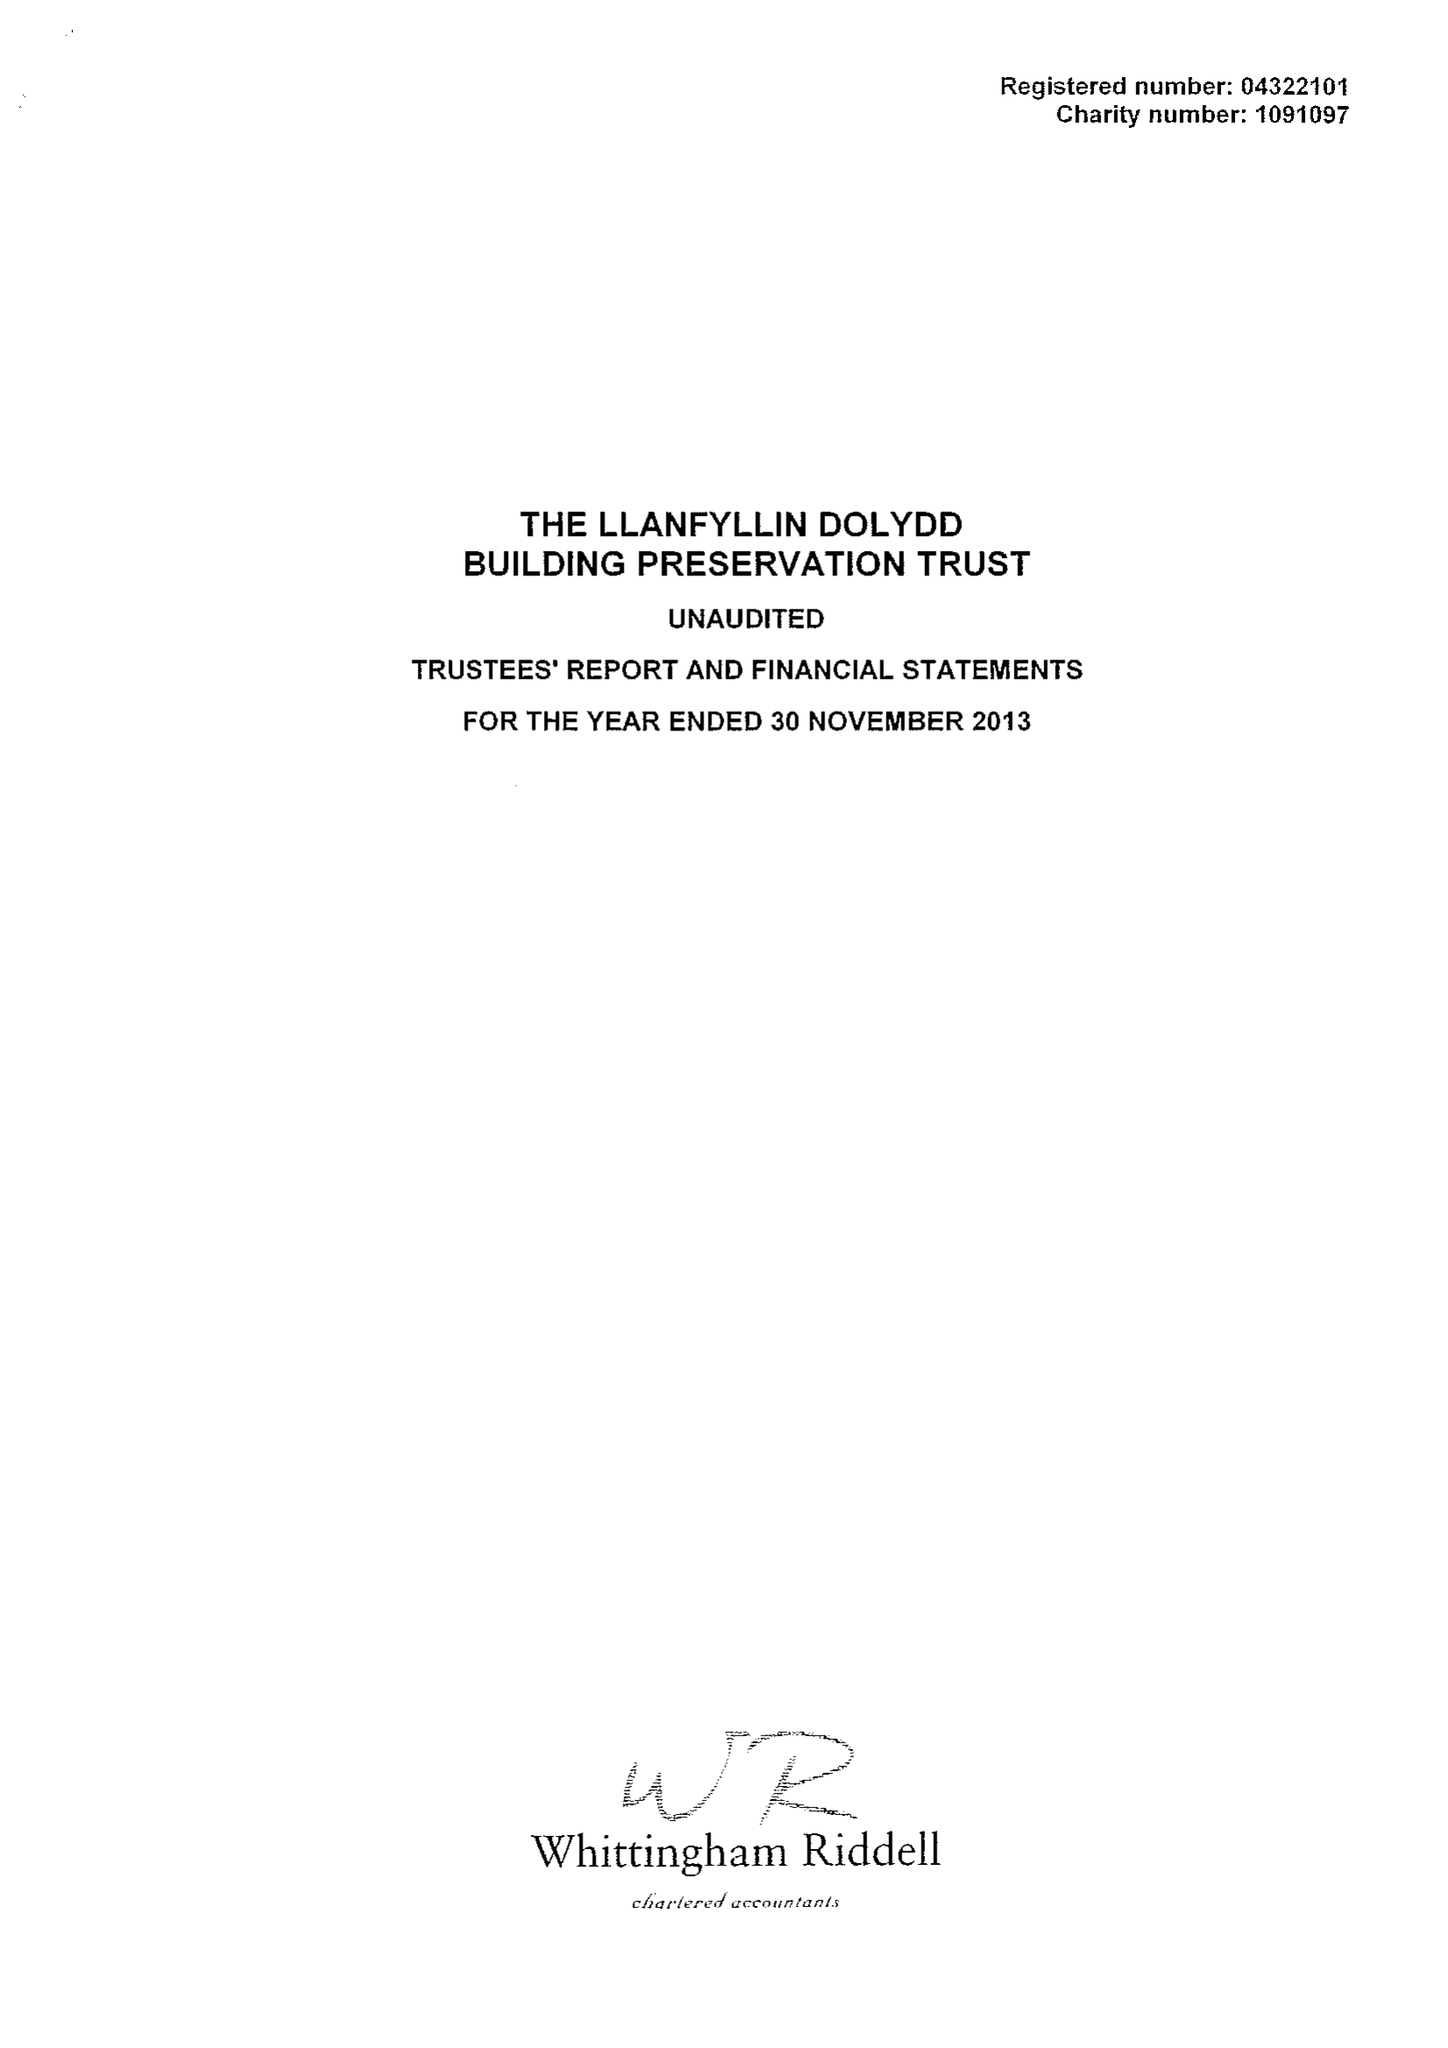What is the value for the spending_annually_in_british_pounds?
Answer the question using a single word or phrase. 43788.00 